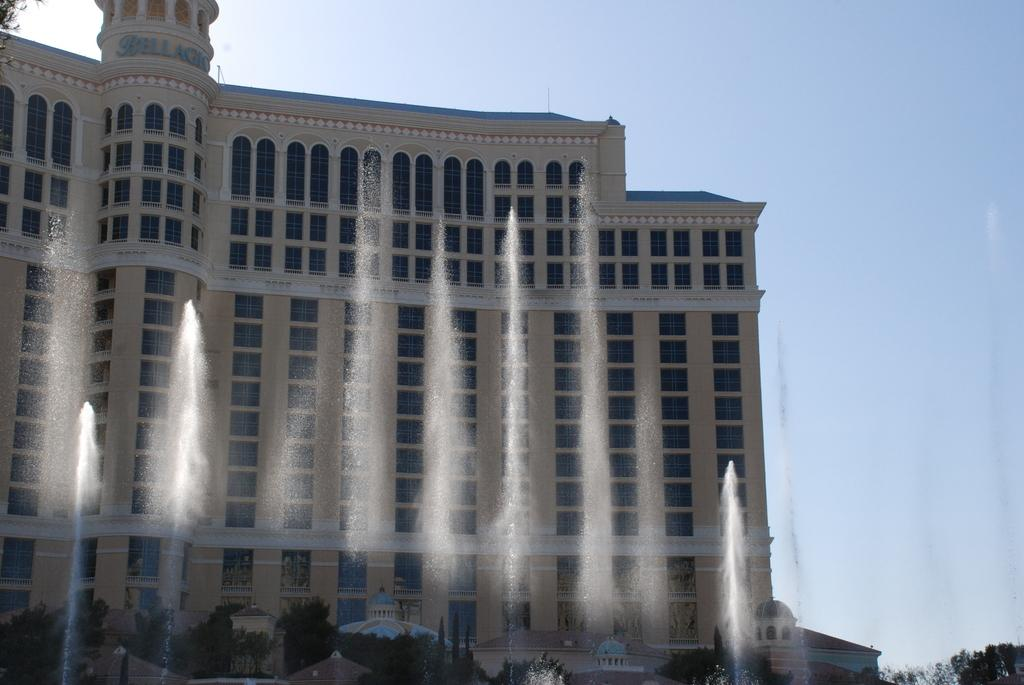What is the main structure in the center of the image? There is a building in the center of the image. What natural features can be seen in the foreground of the image? There are waterfalls and trees in the foreground of the image. Are there any other structures visible in the foreground? Yes, there are other buildings in the foreground of the image. What can be seen in the background of the image? There is sky visible in the background of the image. What type of stew is being served at the committee meeting in the image? There is no committee meeting or stew present in the image; it features a building, waterfalls, trees, and other buildings. 